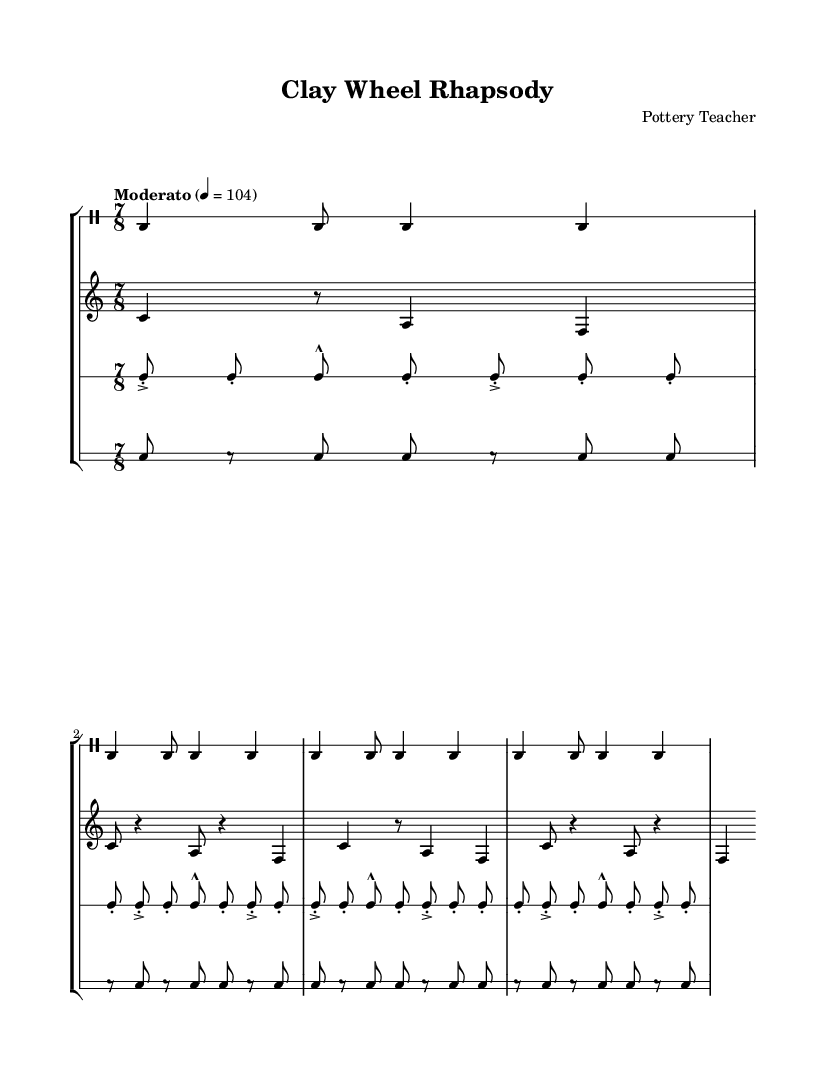What is the time signature of this music? The time signature shown in all staff sections is 7/8, indicating there are seven beats per measure with an eighth note receiving one beat.
Answer: 7/8 What is the tempo marking of the composition? The tempo marking indicates "Moderato" with a metronome marking of "4 = 104", meaning a moderate speed of 104 beats per minute.
Answer: Moderato, 4 = 104 How many beats are in one measure of the pottery wheel rhythm? In the pottery wheel rhythm section, the time signature 7/8 specifies that there are seven beats per measure.
Answer: 7 What is the highest pitch note used in the ceramic bowls staff? The highest pitch note in the ceramic bowls staff is "c'", which is indicated in the notation.
Answer: c' Which rhythmic pattern repeats consistently in the clay tiles section? The repeating pattern is comprised of eighth notes with varying articulations; a combination of accented and non-accented notes with a total of seven counts per measure, consistent with the 7/8 time signature.
Answer: A combination of eighth notes How does the rhythm of the terracotta pots differ from the other sections? The rhythm of the terracotta pots section features more rests between the notes, creating a distinct and fragmented rhythmic texture compared to the more continuous patterns found in the other sections.
Answer: More rests What visual feature distinguishes the pottery wheel staff? The pottery wheel staff has a single-line staff system, which is unique among the other staves that generally have multiple lines, emphasizing the percussive nature of the composition.
Answer: Single-line staff 